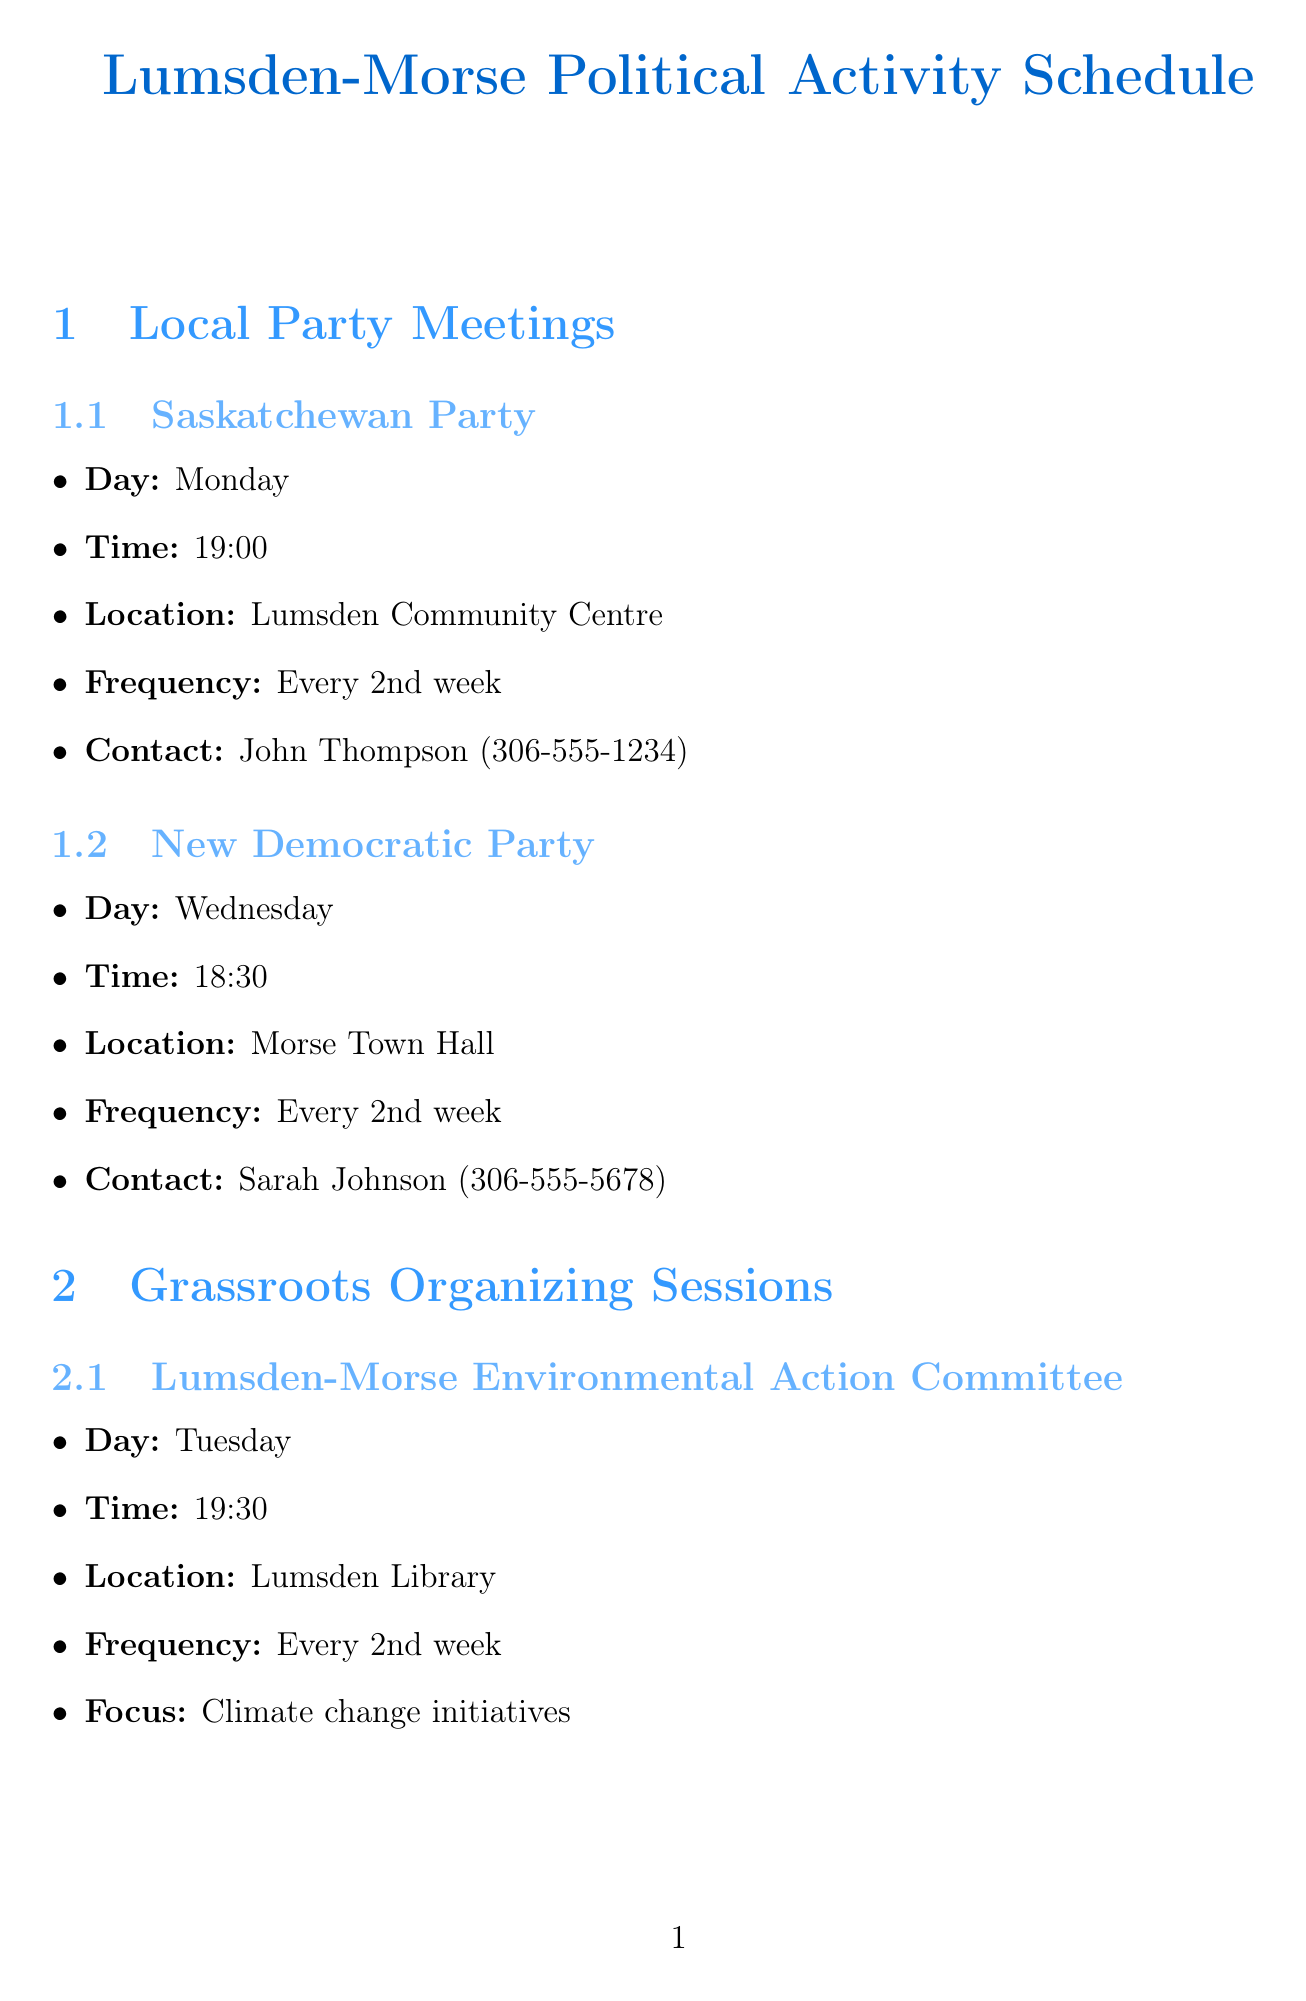what day does the Saskatchewan Party meet? The document specifies that the Saskatchewan Party meets on Monday.
Answer: Monday what time is the next meeting of the New Democratic Party? According to the document, the next meeting is scheduled for 18:30.
Answer: 18:30 where do the grassroots organizing sessions for the Lumsden-Morse Environmental Action Committee take place? The document states that the organizing sessions are held at the Lumsden Library.
Answer: Lumsden Library which political workshop is organized by the Saskatchewan Political Action Network? The document lists "Effective Campaigning Strategies" as the workshop organized by the Saskatchewan Political Action Network.
Answer: Effective Campaigning Strategies how often are the community forums held? The document indicates that the community forums are held monthly.
Answer: Monthly what is the focus of the Rural Healthcare Advocates organizing sessions? According to the document, the focus is on improving rural healthcare access.
Answer: Improving rural healthcare access who is the contact person for the Saskatchewan Party meetings? The document states that the contact person for the Saskatchewan Party is John Thompson.
Answer: John Thompson what is the location of MLA Jane Smith's office? The document specifies that MLA Jane Smith's office is located at 123 Main Street, Lumsden.
Answer: 123 Main Street, Lumsden when is the next grassroots organizing session after Tuesday? The organizing session for the Lumsden-Morse Environmental Action Committee is on Tuesday, and the next one would be in two weeks, specifically on Tuesday again.
Answer: Tuesday 